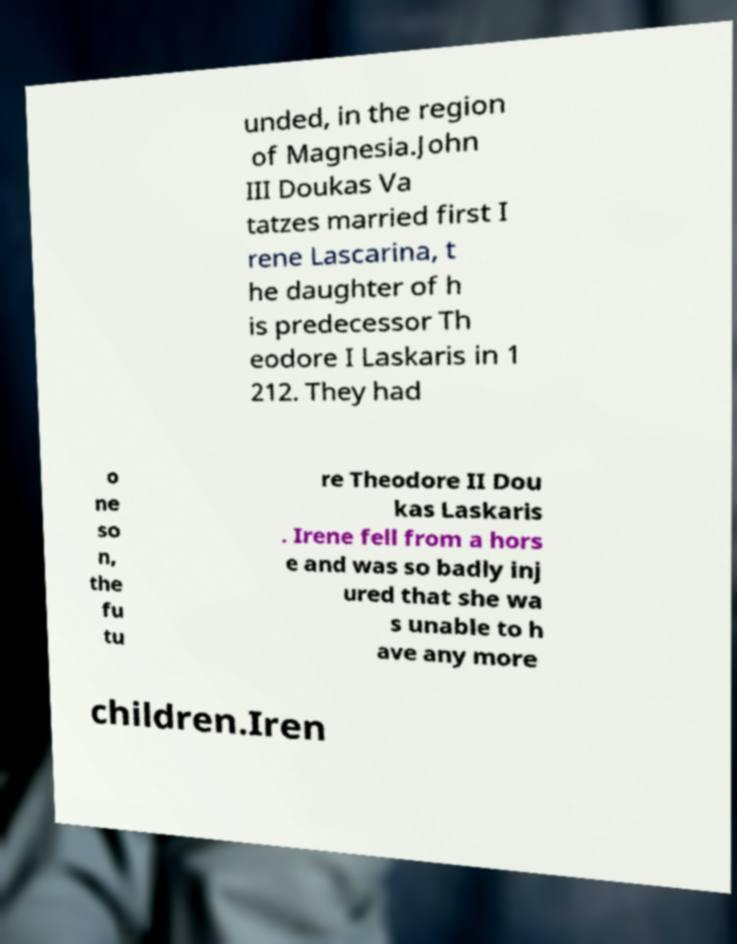Can you read and provide the text displayed in the image?This photo seems to have some interesting text. Can you extract and type it out for me? unded, in the region of Magnesia.John III Doukas Va tatzes married first I rene Lascarina, t he daughter of h is predecessor Th eodore I Laskaris in 1 212. They had o ne so n, the fu tu re Theodore II Dou kas Laskaris . Irene fell from a hors e and was so badly inj ured that she wa s unable to h ave any more children.Iren 